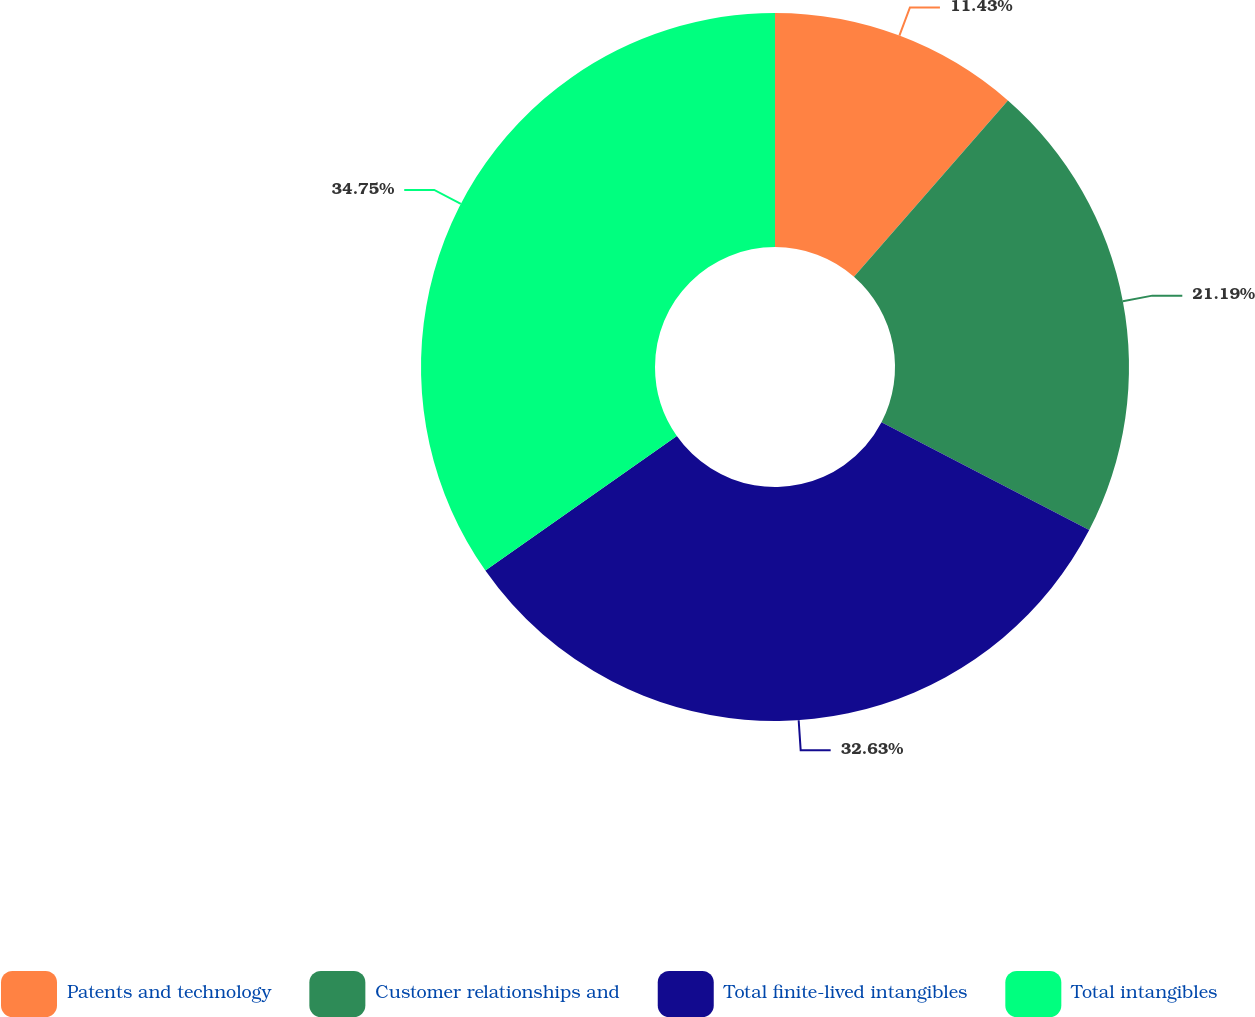Convert chart. <chart><loc_0><loc_0><loc_500><loc_500><pie_chart><fcel>Patents and technology<fcel>Customer relationships and<fcel>Total finite-lived intangibles<fcel>Total intangibles<nl><fcel>11.43%<fcel>21.19%<fcel>32.63%<fcel>34.75%<nl></chart> 